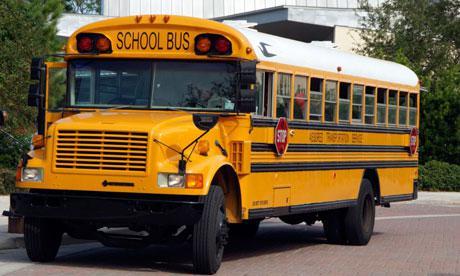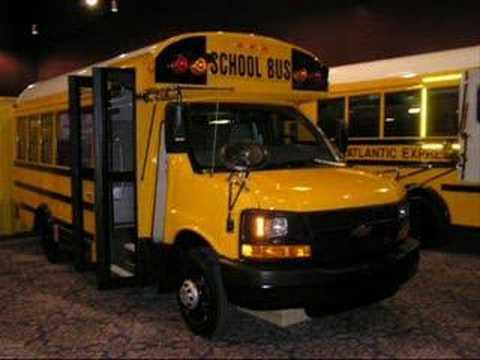The first image is the image on the left, the second image is the image on the right. Given the left and right images, does the statement "Each image shows a bus with a non-flat front that is facing toward the camera." hold true? Answer yes or no. Yes. The first image is the image on the left, the second image is the image on the right. Given the left and right images, does the statement "The left and right image contains the same number of buses that are facing somewhat forward." hold true? Answer yes or no. No. 